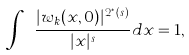Convert formula to latex. <formula><loc_0><loc_0><loc_500><loc_500>\int _ { \mathbb { R } ^ { n } } \frac { | w _ { k } ( x , 0 ) | ^ { 2 _ { \alpha } ^ { * } ( s ) } } { | x | ^ { s } } d x = 1 ,</formula> 